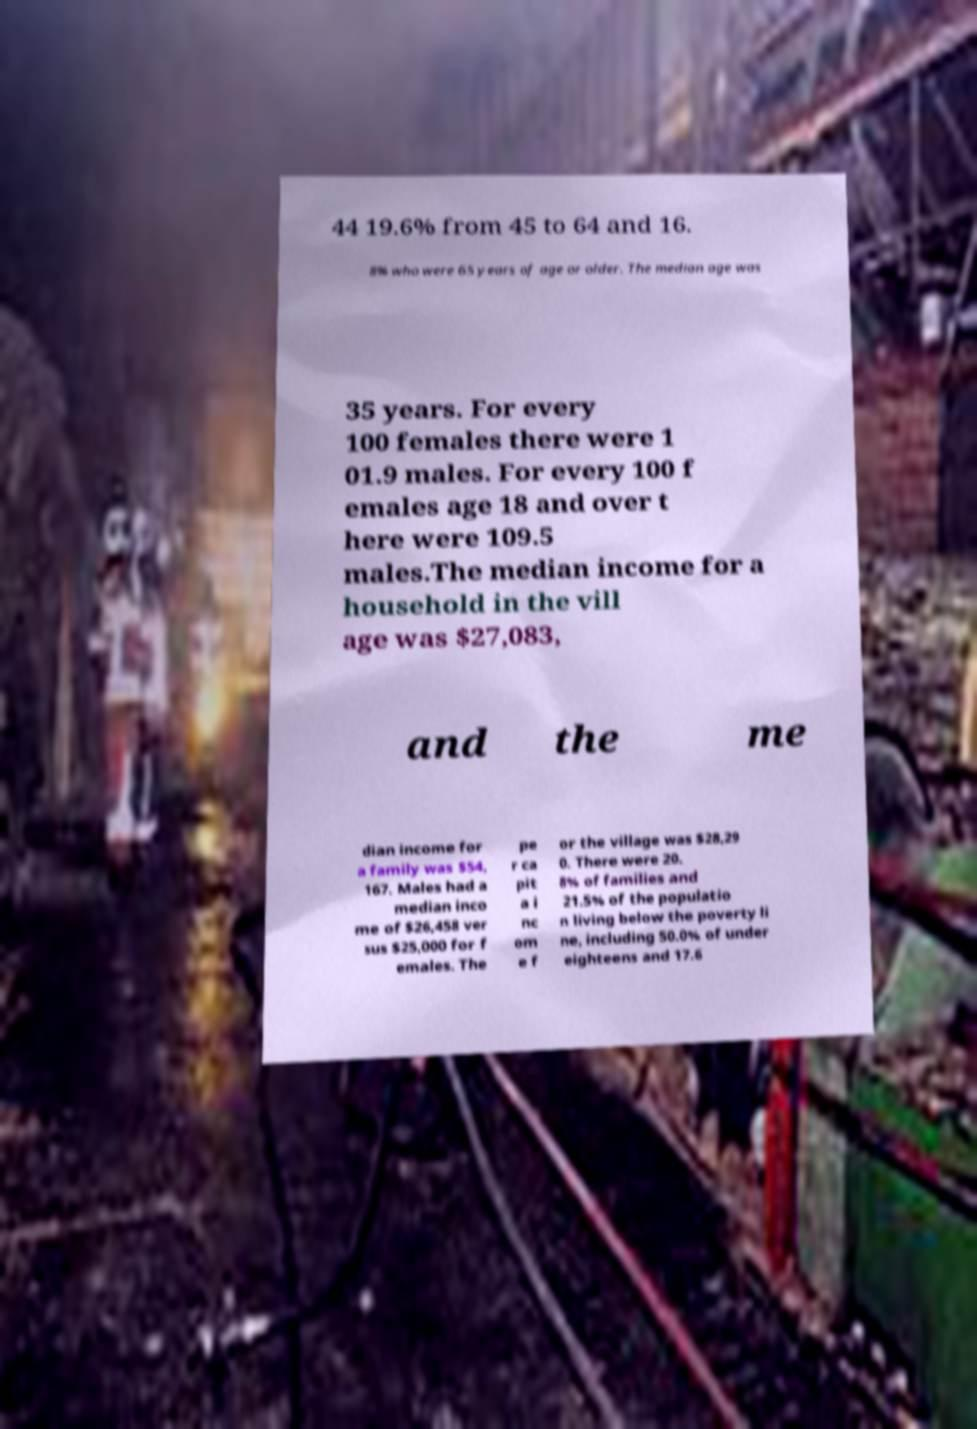I need the written content from this picture converted into text. Can you do that? 44 19.6% from 45 to 64 and 16. 8% who were 65 years of age or older. The median age was 35 years. For every 100 females there were 1 01.9 males. For every 100 f emales age 18 and over t here were 109.5 males.The median income for a household in the vill age was $27,083, and the me dian income for a family was $54, 167. Males had a median inco me of $26,458 ver sus $25,000 for f emales. The pe r ca pit a i nc om e f or the village was $28,29 0. There were 20. 8% of families and 21.5% of the populatio n living below the poverty li ne, including 50.0% of under eighteens and 17.6 